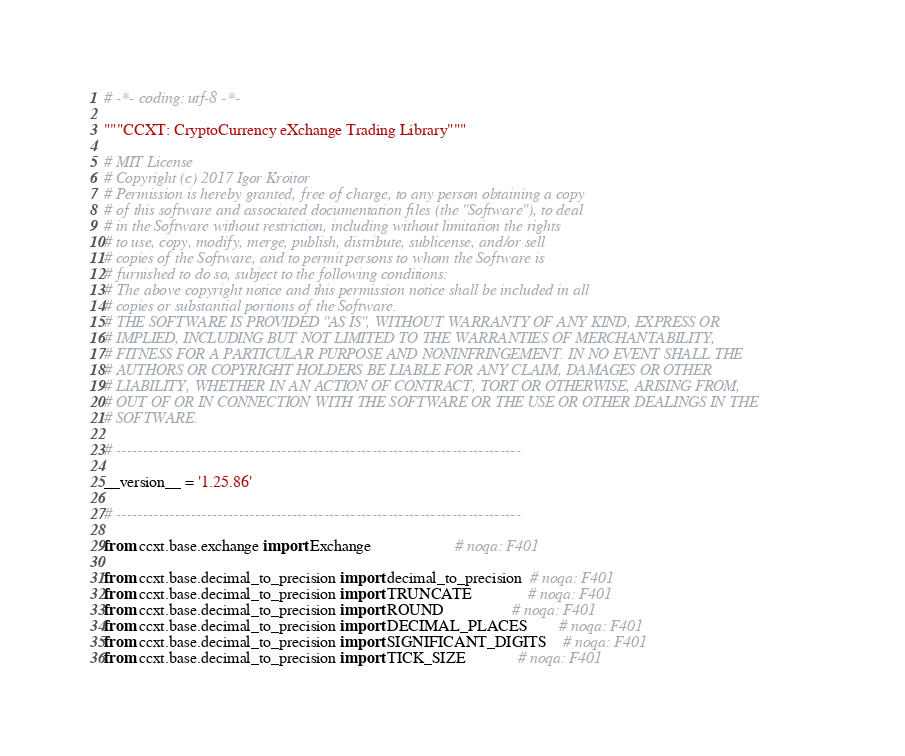Convert code to text. <code><loc_0><loc_0><loc_500><loc_500><_Python_># -*- coding: utf-8 -*-

"""CCXT: CryptoCurrency eXchange Trading Library"""

# MIT License
# Copyright (c) 2017 Igor Kroitor
# Permission is hereby granted, free of charge, to any person obtaining a copy
# of this software and associated documentation files (the "Software"), to deal
# in the Software without restriction, including without limitation the rights
# to use, copy, modify, merge, publish, distribute, sublicense, and/or sell
# copies of the Software, and to permit persons to whom the Software is
# furnished to do so, subject to the following conditions:
# The above copyright notice and this permission notice shall be included in all
# copies or substantial portions of the Software.
# THE SOFTWARE IS PROVIDED "AS IS", WITHOUT WARRANTY OF ANY KIND, EXPRESS OR
# IMPLIED, INCLUDING BUT NOT LIMITED TO THE WARRANTIES OF MERCHANTABILITY,
# FITNESS FOR A PARTICULAR PURPOSE AND NONINFRINGEMENT. IN NO EVENT SHALL THE
# AUTHORS OR COPYRIGHT HOLDERS BE LIABLE FOR ANY CLAIM, DAMAGES OR OTHER
# LIABILITY, WHETHER IN AN ACTION OF CONTRACT, TORT OR OTHERWISE, ARISING FROM,
# OUT OF OR IN CONNECTION WITH THE SOFTWARE OR THE USE OR OTHER DEALINGS IN THE
# SOFTWARE.

# ----------------------------------------------------------------------------

__version__ = '1.25.86'

# ----------------------------------------------------------------------------

from ccxt.base.exchange import Exchange                     # noqa: F401

from ccxt.base.decimal_to_precision import decimal_to_precision  # noqa: F401
from ccxt.base.decimal_to_precision import TRUNCATE              # noqa: F401
from ccxt.base.decimal_to_precision import ROUND                 # noqa: F401
from ccxt.base.decimal_to_precision import DECIMAL_PLACES        # noqa: F401
from ccxt.base.decimal_to_precision import SIGNIFICANT_DIGITS    # noqa: F401
from ccxt.base.decimal_to_precision import TICK_SIZE             # noqa: F401</code> 